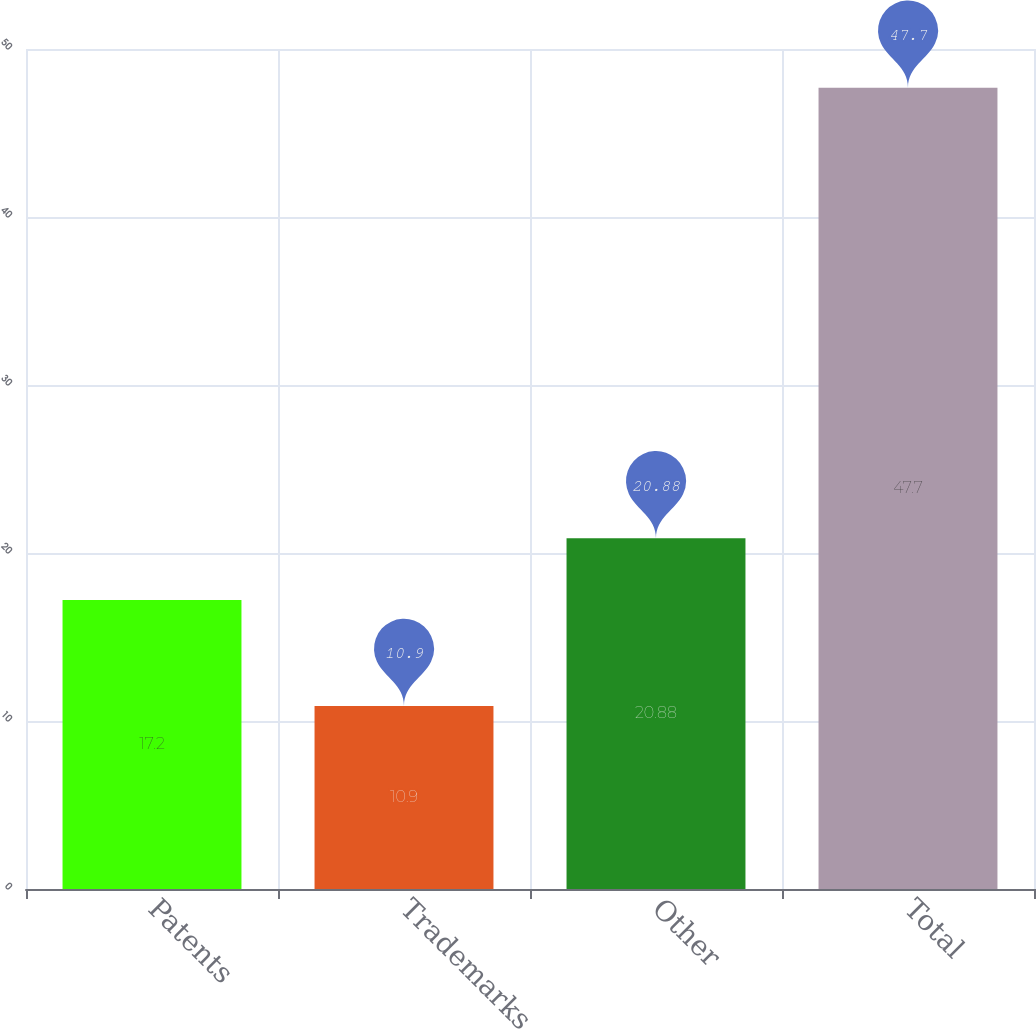<chart> <loc_0><loc_0><loc_500><loc_500><bar_chart><fcel>Patents<fcel>Trademarks<fcel>Other<fcel>Total<nl><fcel>17.2<fcel>10.9<fcel>20.88<fcel>47.7<nl></chart> 